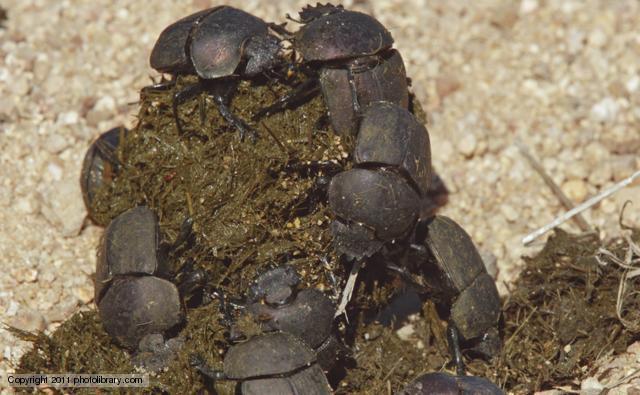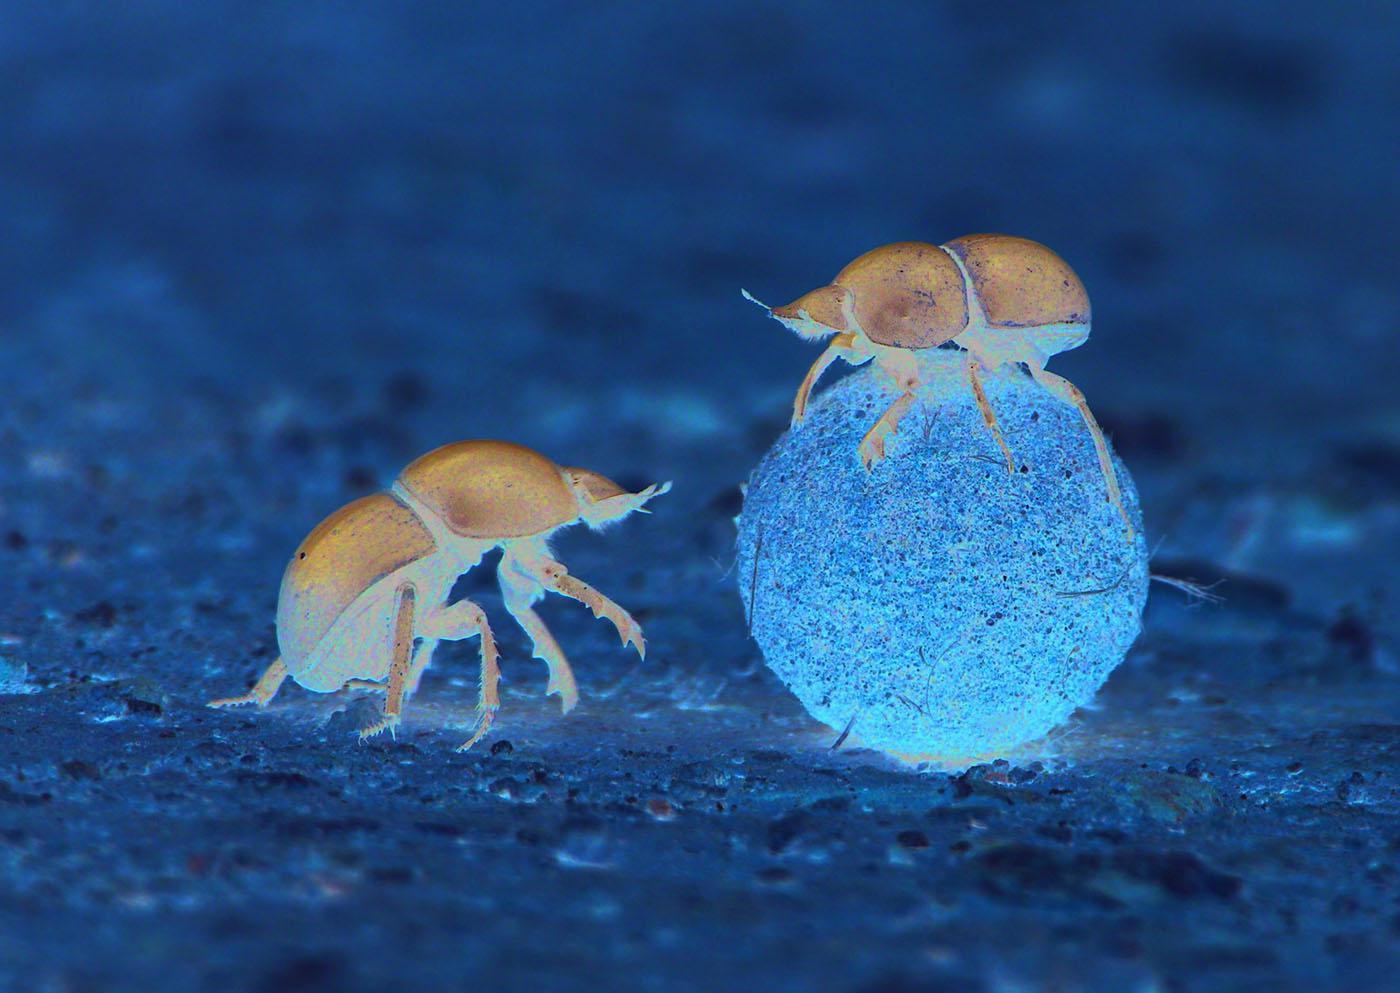The first image is the image on the left, the second image is the image on the right. For the images shown, is this caption "Each image has at least 2 dung beetles with a ball of dung." true? Answer yes or no. Yes. The first image is the image on the left, the second image is the image on the right. For the images displayed, is the sentence "There are two dung beetles." factually correct? Answer yes or no. No. 